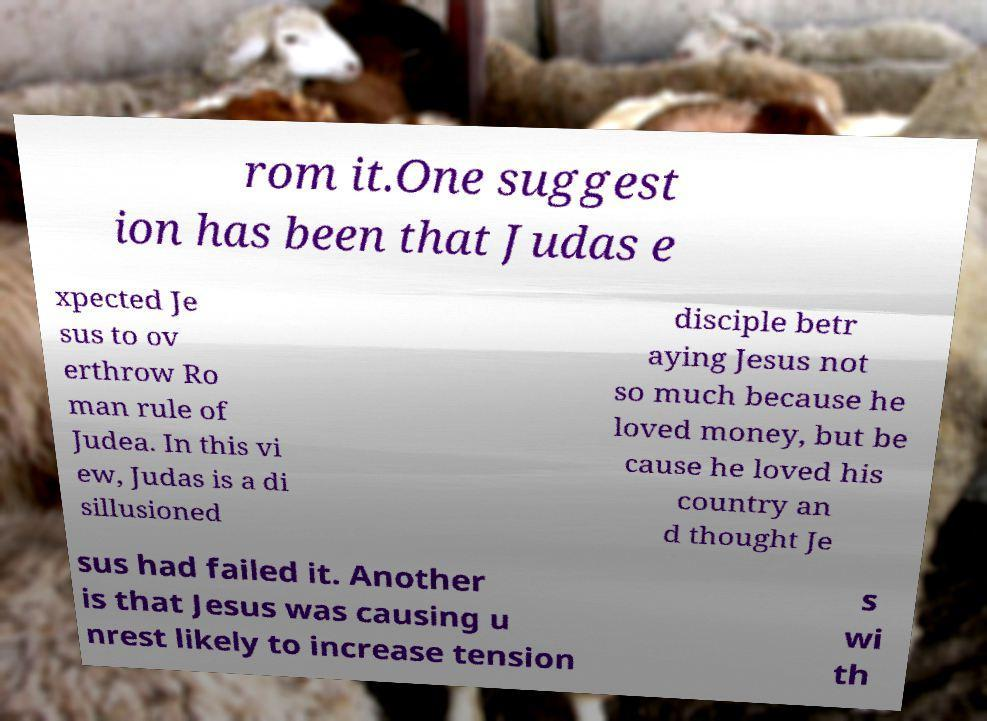Please identify and transcribe the text found in this image. rom it.One suggest ion has been that Judas e xpected Je sus to ov erthrow Ro man rule of Judea. In this vi ew, Judas is a di sillusioned disciple betr aying Jesus not so much because he loved money, but be cause he loved his country an d thought Je sus had failed it. Another is that Jesus was causing u nrest likely to increase tension s wi th 